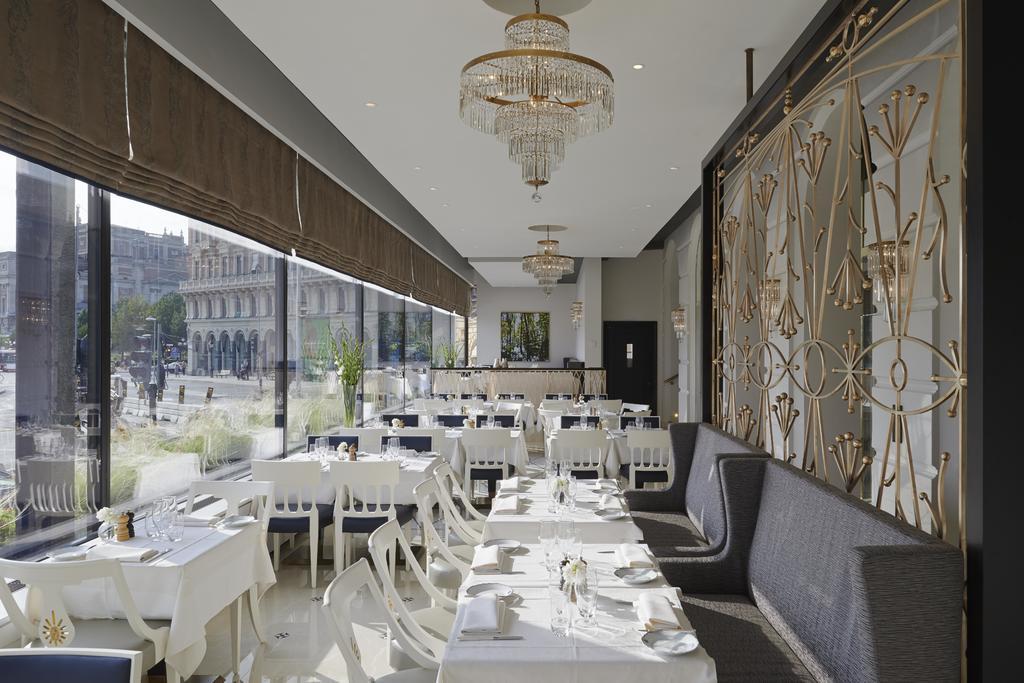Could you give a brief overview of what you see in this image? In this image we can see there are some chairs, sofas and tables, on the tables, we can see some clothes, plates and other objects, there is a photo frame on the wall, at the top we can see chandeliers, through the glass we can see some buildings and trees. 